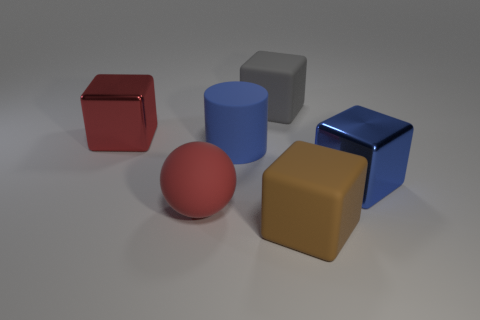Is there any other thing that has the same shape as the big red rubber thing?
Provide a short and direct response. No. Is the material of the large ball the same as the blue object to the left of the large gray block?
Offer a terse response. Yes. Are there fewer blue matte cylinders that are on the left side of the big blue rubber object than spheres that are to the right of the red shiny thing?
Offer a very short reply. Yes. There is a block that is left of the big gray matte thing; what is its material?
Provide a succinct answer. Metal. What color is the thing that is behind the rubber sphere and on the left side of the blue rubber cylinder?
Your answer should be compact. Red. What is the color of the matte cube to the right of the gray matte object?
Ensure brevity in your answer.  Brown. Is there a cyan rubber cylinder of the same size as the brown object?
Give a very brief answer. No. There is a blue cylinder that is the same size as the red cube; what is it made of?
Your response must be concise. Rubber. What number of objects are either big rubber blocks that are in front of the large blue shiny thing or objects that are behind the red cube?
Offer a terse response. 2. Is there a large blue metallic object that has the same shape as the large gray rubber thing?
Make the answer very short. Yes. 